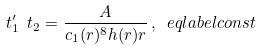<formula> <loc_0><loc_0><loc_500><loc_500>\ t _ { 1 } ^ { \prime } \ t _ { 2 } = \frac { A } { c _ { 1 } ( r ) ^ { 8 } h ( r ) r } \, , \ e q l a b e l { c o n s t }</formula> 